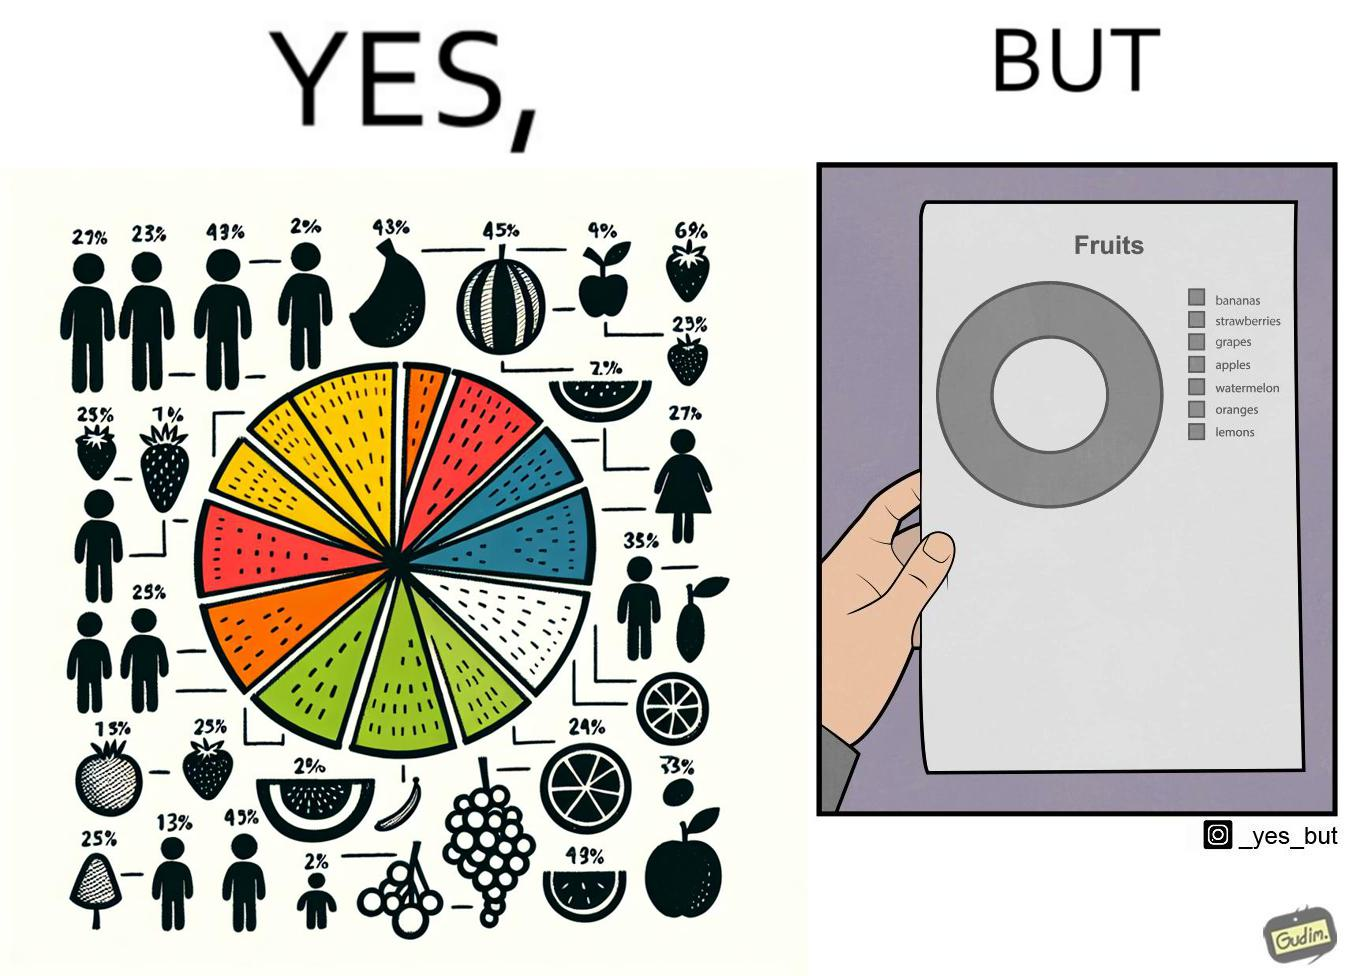Why is this image considered satirical? This is funny because the pie chart printout is useless as you cant see any divisions on it because the  printer could not capture the different colors 